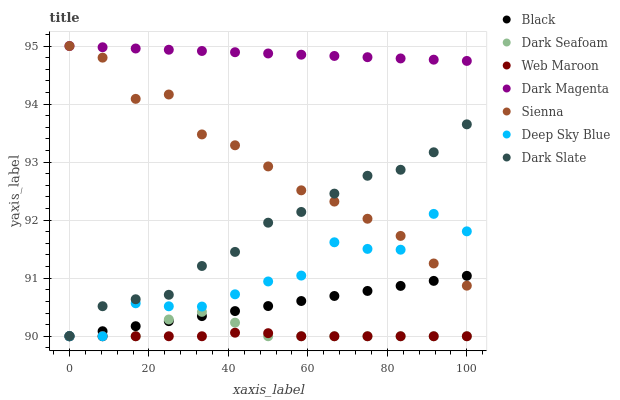Does Web Maroon have the minimum area under the curve?
Answer yes or no. Yes. Does Dark Magenta have the maximum area under the curve?
Answer yes or no. Yes. Does Sienna have the minimum area under the curve?
Answer yes or no. No. Does Sienna have the maximum area under the curve?
Answer yes or no. No. Is Dark Magenta the smoothest?
Answer yes or no. Yes. Is Deep Sky Blue the roughest?
Answer yes or no. Yes. Is Web Maroon the smoothest?
Answer yes or no. No. Is Web Maroon the roughest?
Answer yes or no. No. Does Web Maroon have the lowest value?
Answer yes or no. Yes. Does Sienna have the lowest value?
Answer yes or no. No. Does Sienna have the highest value?
Answer yes or no. Yes. Does Web Maroon have the highest value?
Answer yes or no. No. Is Dark Seafoam less than Sienna?
Answer yes or no. Yes. Is Sienna greater than Web Maroon?
Answer yes or no. Yes. Does Dark Seafoam intersect Black?
Answer yes or no. Yes. Is Dark Seafoam less than Black?
Answer yes or no. No. Is Dark Seafoam greater than Black?
Answer yes or no. No. Does Dark Seafoam intersect Sienna?
Answer yes or no. No. 